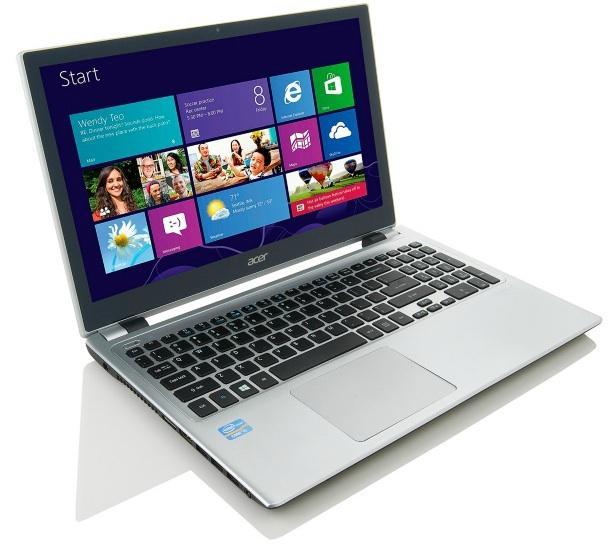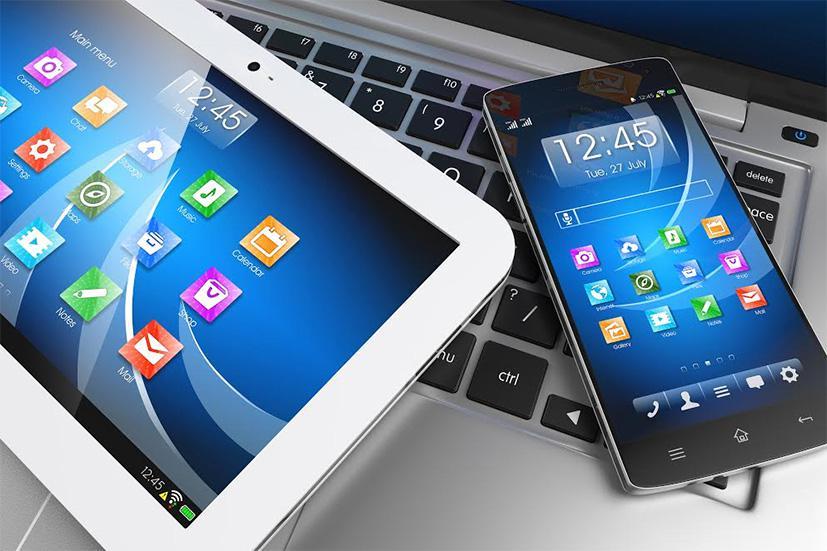The first image is the image on the left, the second image is the image on the right. For the images displayed, is the sentence "One image includes a phone resting on a keyboard and near a device with a larger screen rimmed in white." factually correct? Answer yes or no. Yes. The first image is the image on the left, the second image is the image on the right. Examine the images to the left and right. Is the description "A smartphone and a tablet are laying on top of a laptop keyboard." accurate? Answer yes or no. Yes. 